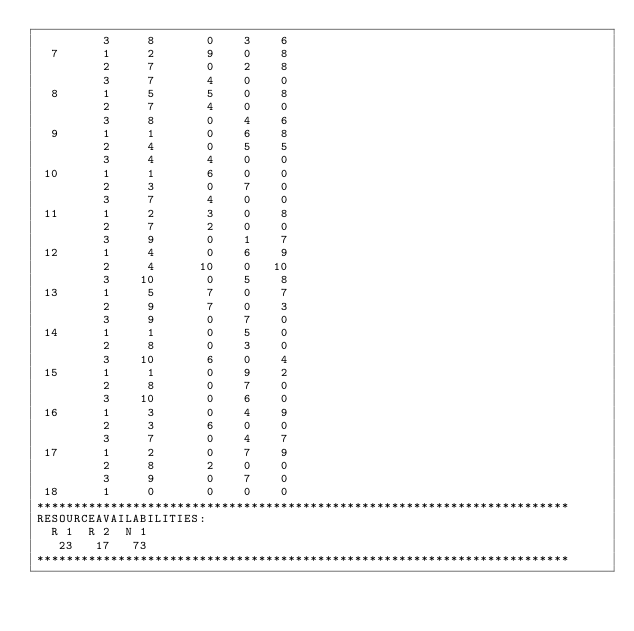<code> <loc_0><loc_0><loc_500><loc_500><_ObjectiveC_>         3     8       0    3    6
  7      1     2       9    0    8
         2     7       0    2    8
         3     7       4    0    0
  8      1     5       5    0    8
         2     7       4    0    0
         3     8       0    4    6
  9      1     1       0    6    8
         2     4       0    5    5
         3     4       4    0    0
 10      1     1       6    0    0
         2     3       0    7    0
         3     7       4    0    0
 11      1     2       3    0    8
         2     7       2    0    0
         3     9       0    1    7
 12      1     4       0    6    9
         2     4      10    0   10
         3    10       0    5    8
 13      1     5       7    0    7
         2     9       7    0    3
         3     9       0    7    0
 14      1     1       0    5    0
         2     8       0    3    0
         3    10       6    0    4
 15      1     1       0    9    2
         2     8       0    7    0
         3    10       0    6    0
 16      1     3       0    4    9
         2     3       6    0    0
         3     7       0    4    7
 17      1     2       0    7    9
         2     8       2    0    0
         3     9       0    7    0
 18      1     0       0    0    0
************************************************************************
RESOURCEAVAILABILITIES:
  R 1  R 2  N 1
   23   17   73
************************************************************************
</code> 